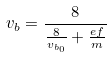Convert formula to latex. <formula><loc_0><loc_0><loc_500><loc_500>v _ { b } = \frac { 8 } { \frac { 8 } { v _ { b _ { 0 } } } + \frac { e f } { m } }</formula> 